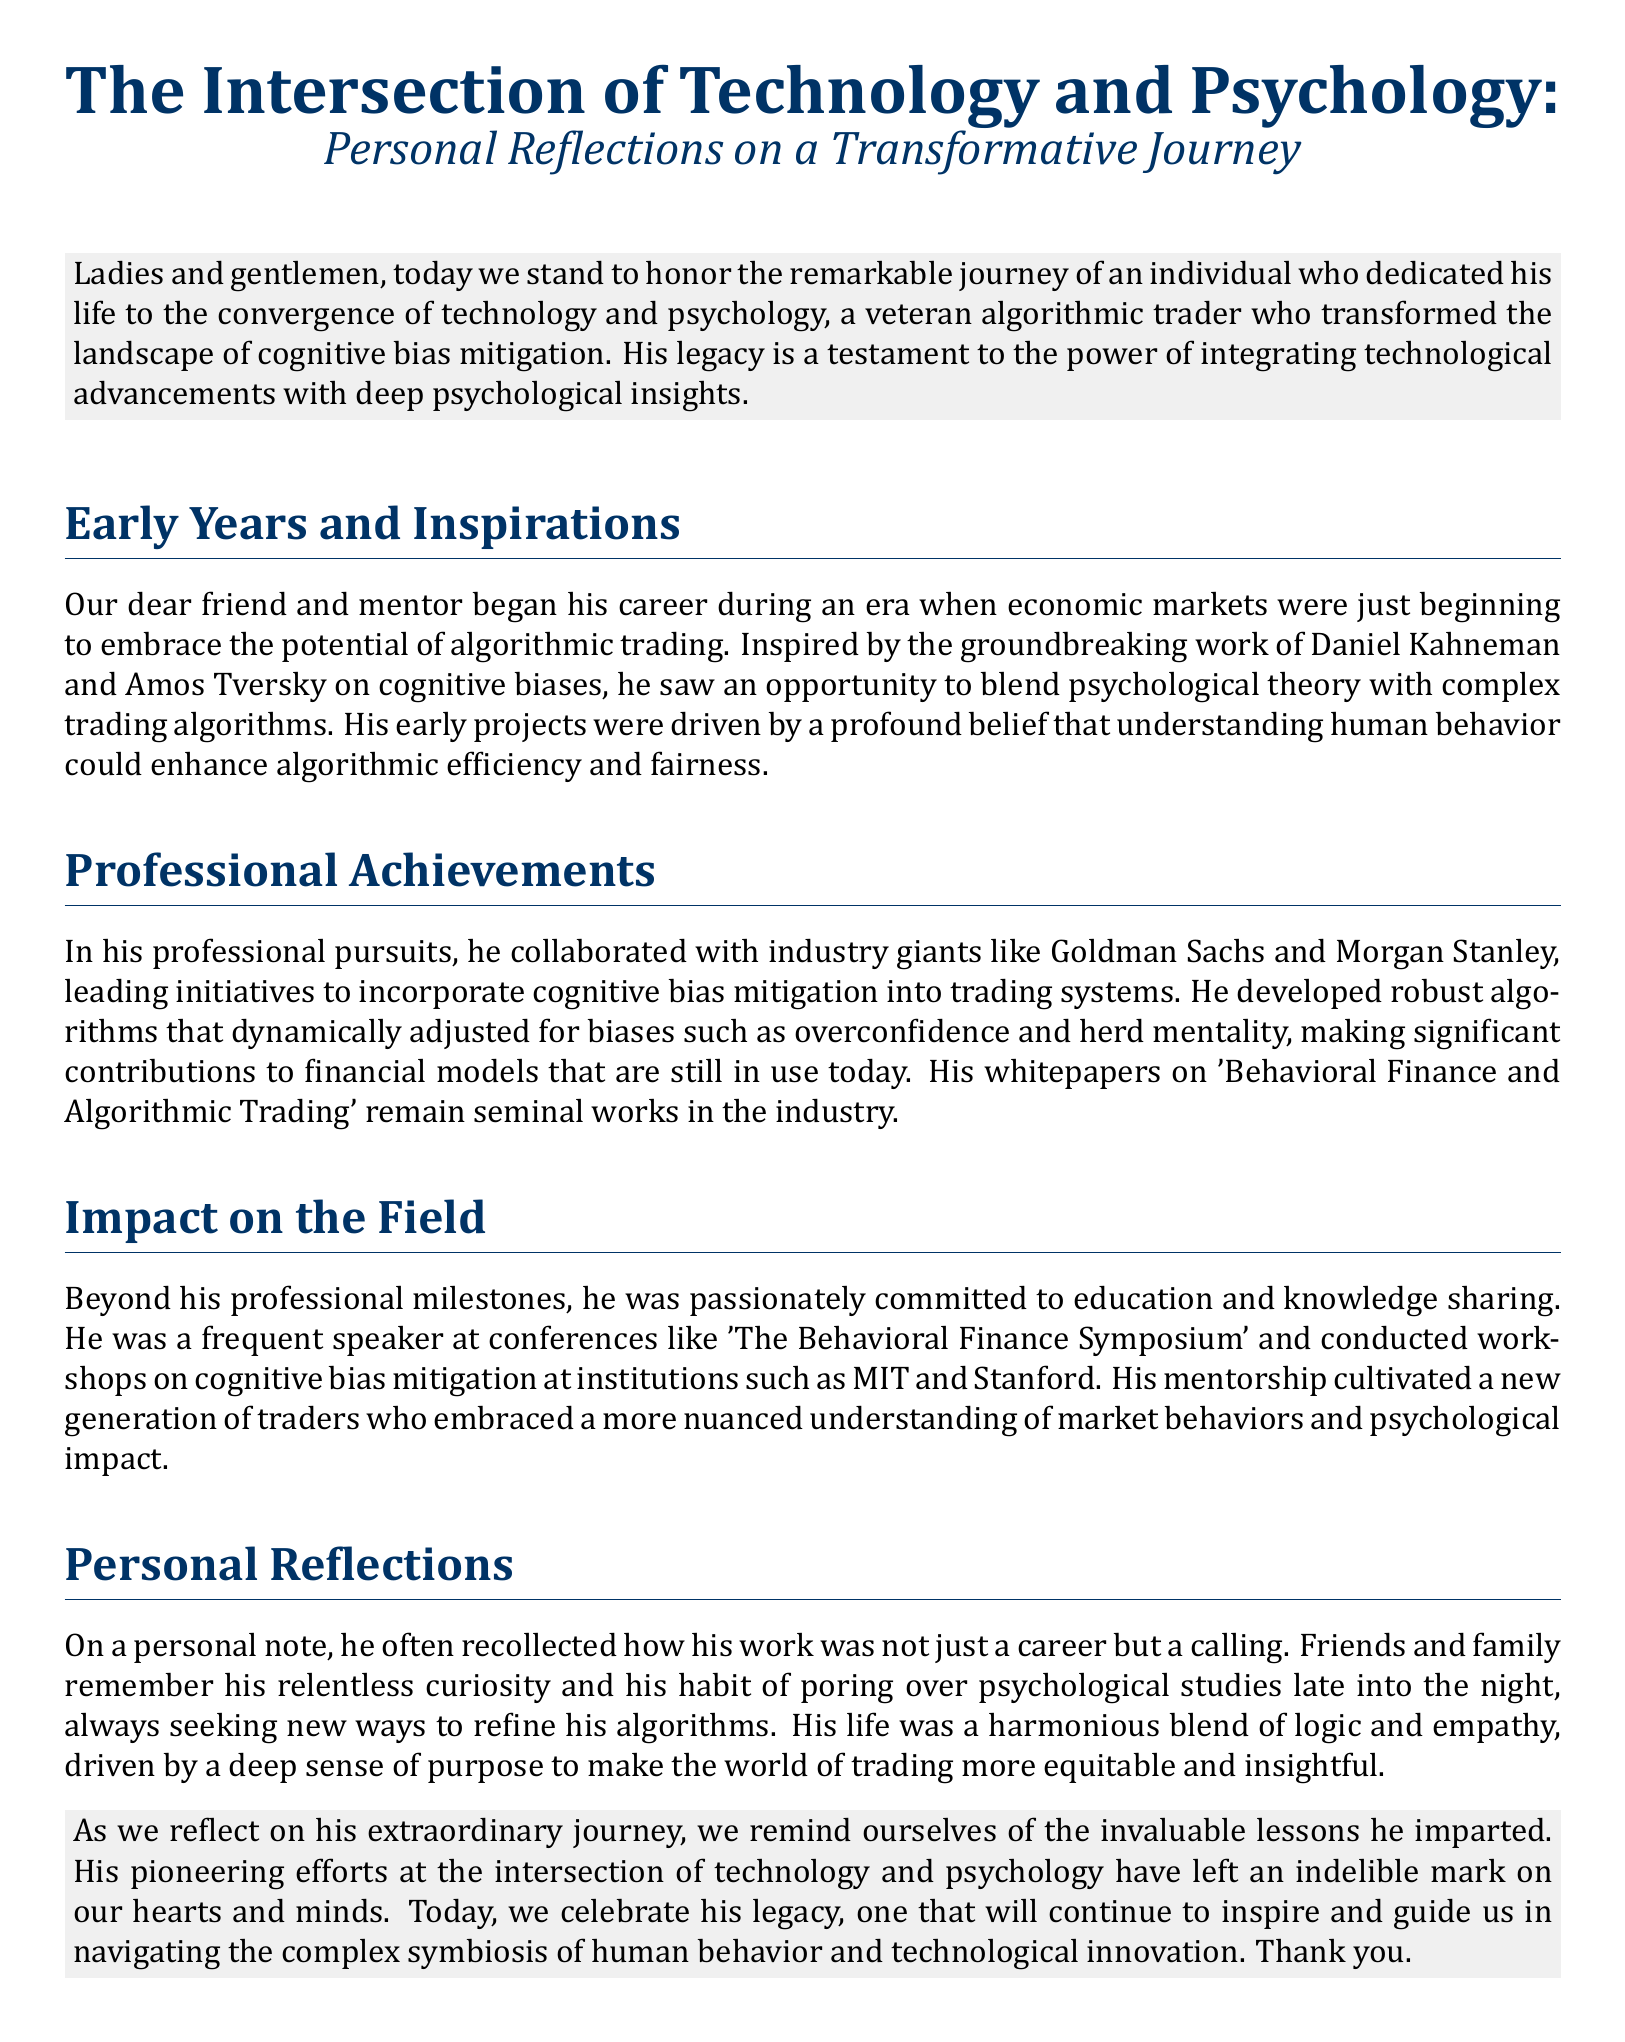What is the main theme of the eulogy? The main theme of the eulogy is the convergence of technology and psychology in the context of cognitive bias mitigation.
Answer: Convergence of technology and psychology Who is the individual being honored? The individual being honored is a veteran algorithmic trader who transformed the landscape of cognitive bias mitigation.
Answer: A veteran algorithmic trader Which two psychologists inspired his early career? The two psychologists are Daniel Kahneman and Amos Tversky.
Answer: Daniel Kahneman and Amos Tversky What industry giants did he collaborate with? He collaborated with industry giants like Goldman Sachs and Morgan Stanley.
Answer: Goldman Sachs and Morgan Stanley What notable event did he frequently speak at? He frequently spoke at the Behavioral Finance Symposium.
Answer: Behavioral Finance Symposium What habit did he have that reflected his curiosity? He had a habit of poring over psychological studies late into the night.
Answer: Poring over psychological studies What was the focus of his whitepapers? His whitepapers focused on Behavioral Finance and Algorithmic Trading.
Answer: Behavioral Finance and Algorithmic Trading What did he consider his work to be? He considered his work to be a calling.
Answer: A calling Which institutions did he conduct workshops at? He conducted workshops at institutions such as MIT and Stanford.
Answer: MIT and Stanford 